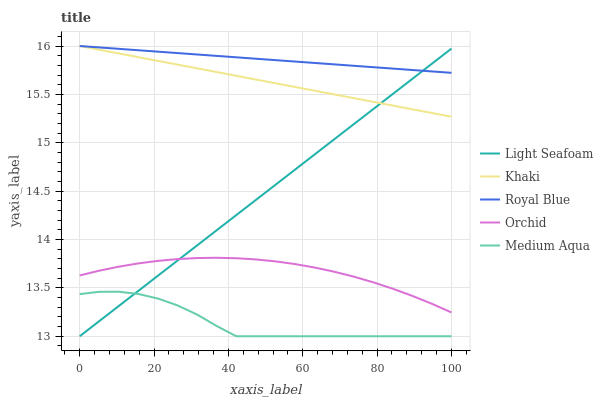Does Medium Aqua have the minimum area under the curve?
Answer yes or no. Yes. Does Royal Blue have the maximum area under the curve?
Answer yes or no. Yes. Does Light Seafoam have the minimum area under the curve?
Answer yes or no. No. Does Light Seafoam have the maximum area under the curve?
Answer yes or no. No. Is Khaki the smoothest?
Answer yes or no. Yes. Is Medium Aqua the roughest?
Answer yes or no. Yes. Is Light Seafoam the smoothest?
Answer yes or no. No. Is Light Seafoam the roughest?
Answer yes or no. No. Does Light Seafoam have the lowest value?
Answer yes or no. Yes. Does Khaki have the lowest value?
Answer yes or no. No. Does Khaki have the highest value?
Answer yes or no. Yes. Does Light Seafoam have the highest value?
Answer yes or no. No. Is Orchid less than Khaki?
Answer yes or no. Yes. Is Royal Blue greater than Medium Aqua?
Answer yes or no. Yes. Does Light Seafoam intersect Orchid?
Answer yes or no. Yes. Is Light Seafoam less than Orchid?
Answer yes or no. No. Is Light Seafoam greater than Orchid?
Answer yes or no. No. Does Orchid intersect Khaki?
Answer yes or no. No. 